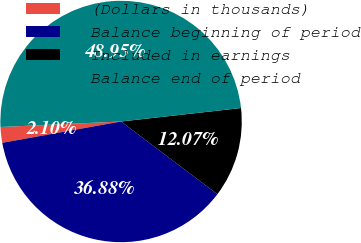Convert chart to OTSL. <chart><loc_0><loc_0><loc_500><loc_500><pie_chart><fcel>(Dollars in thousands)<fcel>Balance beginning of period<fcel>Included in earnings<fcel>Balance end of period<nl><fcel>2.1%<fcel>36.88%<fcel>12.07%<fcel>48.95%<nl></chart> 